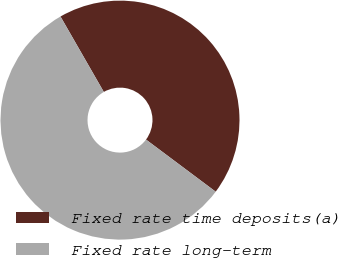Convert chart. <chart><loc_0><loc_0><loc_500><loc_500><pie_chart><fcel>Fixed rate time deposits(a)<fcel>Fixed rate long-term<nl><fcel>43.52%<fcel>56.48%<nl></chart> 